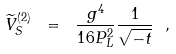<formula> <loc_0><loc_0><loc_500><loc_500>\widetilde { V } _ { S } ^ { ( 2 ) } \ = \ \frac { g ^ { 4 } } { 1 6 P _ { L } ^ { 2 } } \frac { 1 } { \sqrt { - t } } \ ,</formula> 